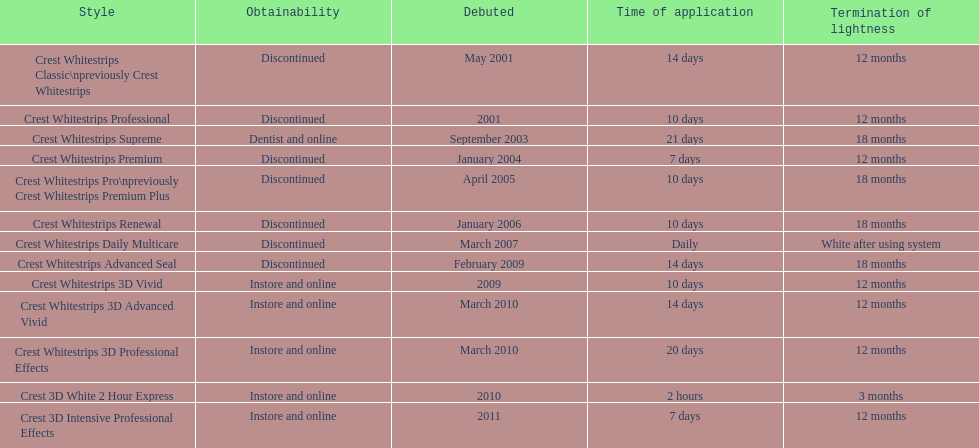How many models require less than a week of use? 2. 